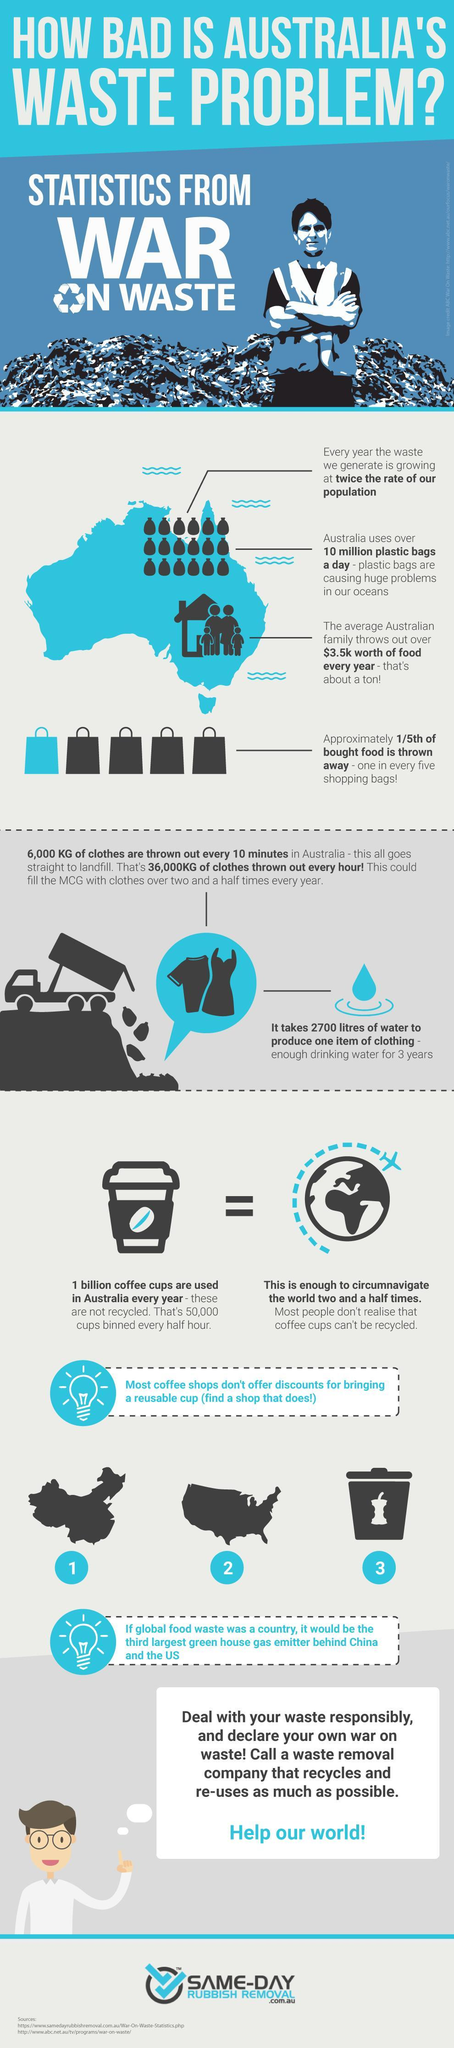How many shopping bags are blue in colour?
Answer the question with a short phrase. 1 How many garbage bags are shown in the infographic? 25 How many sources are listed at the bottom? 2 How many shopping bags are shown in the infographic? 5 